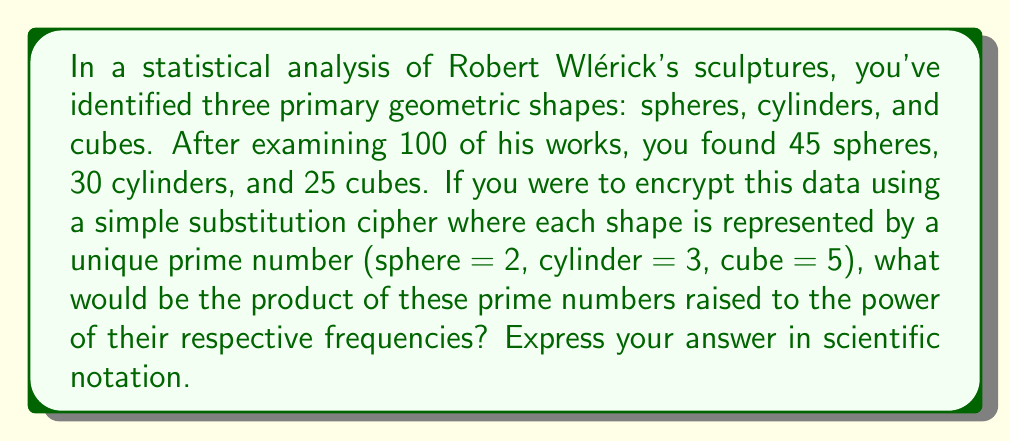Provide a solution to this math problem. Let's approach this step-by-step:

1) We have the following data:
   Spheres: 45
   Cylinders: 30
   Cubes: 25

2) We're assigning prime numbers to each shape:
   Sphere = 2
   Cylinder = 3
   Cube = 5

3) We need to calculate: $2^{45} \times 3^{30} \times 5^{25}$

4) Let's break this down:
   $2^{45} = 3.518437209 \times 10^{13}$
   $3^{30} = 2.058911321 \times 10^{14}$
   $5^{25} = 2.980232239 \times 10^{17}$

5) Now, we multiply these results:
   $(3.518437209 \times 10^{13}) \times (2.058911321 \times 10^{14}) \times (2.980232239 \times 10^{17})$

6) Multiplying the coefficients:
   $3.518437209 \times 2.058911321 \times 2.980232239 = 21.61074687$

7) Adding the exponents:
   $13 + 14 + 17 = 44$

8) Therefore, our final result is:
   $21.61074687 \times 10^{44}$

9) Rounding to 2 decimal places in scientific notation:
   $2.16 \times 10^{45}$
Answer: $2.16 \times 10^{45}$ 